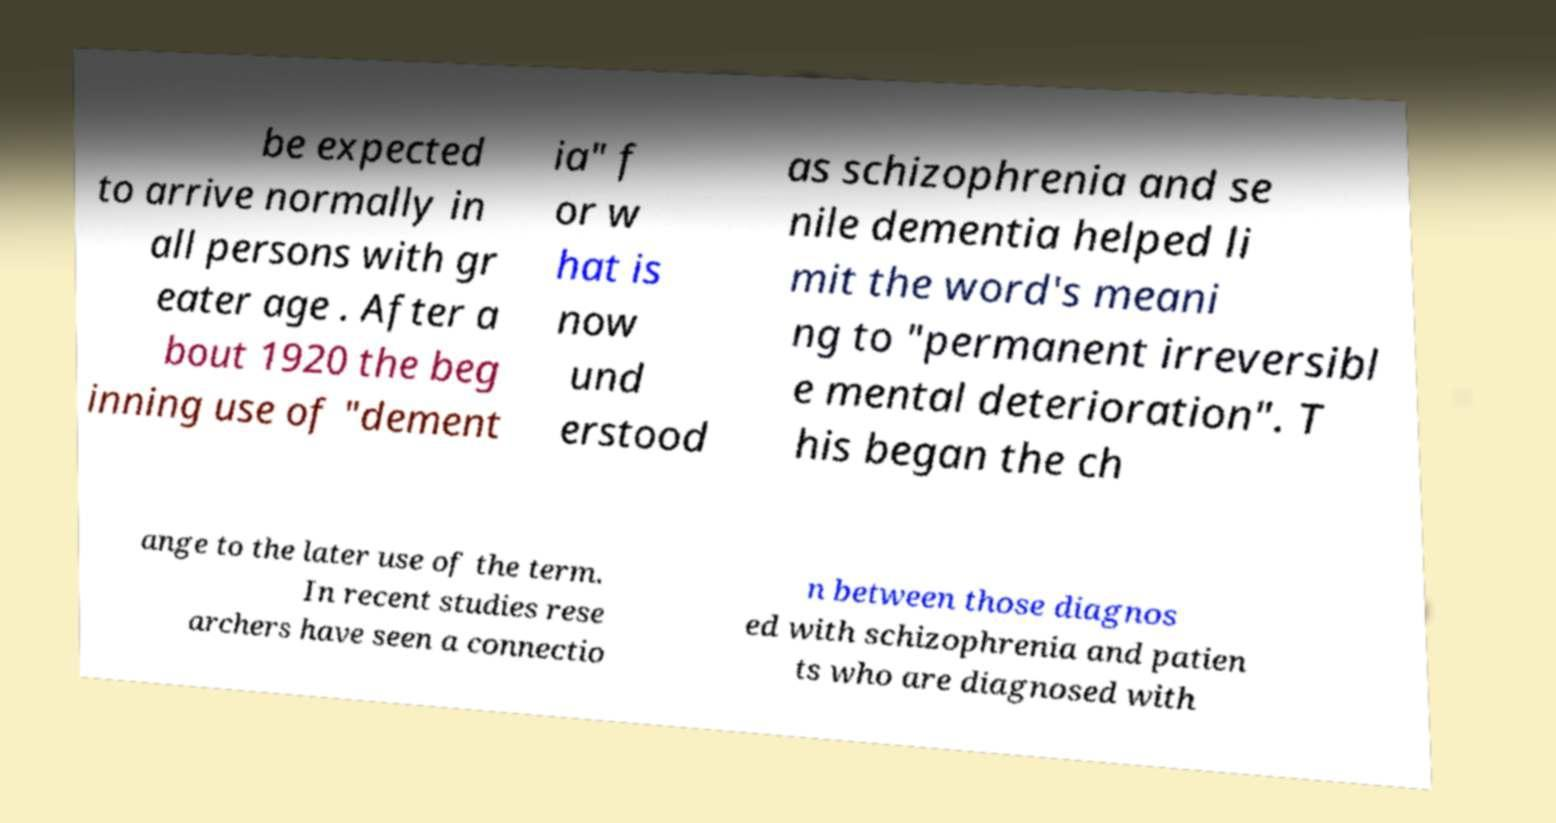I need the written content from this picture converted into text. Can you do that? be expected to arrive normally in all persons with gr eater age . After a bout 1920 the beg inning use of "dement ia" f or w hat is now und erstood as schizophrenia and se nile dementia helped li mit the word's meani ng to "permanent irreversibl e mental deterioration". T his began the ch ange to the later use of the term. In recent studies rese archers have seen a connectio n between those diagnos ed with schizophrenia and patien ts who are diagnosed with 